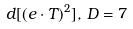<formula> <loc_0><loc_0><loc_500><loc_500>d [ ( e \cdot T ) ^ { 2 } ] , \, D = 7</formula> 